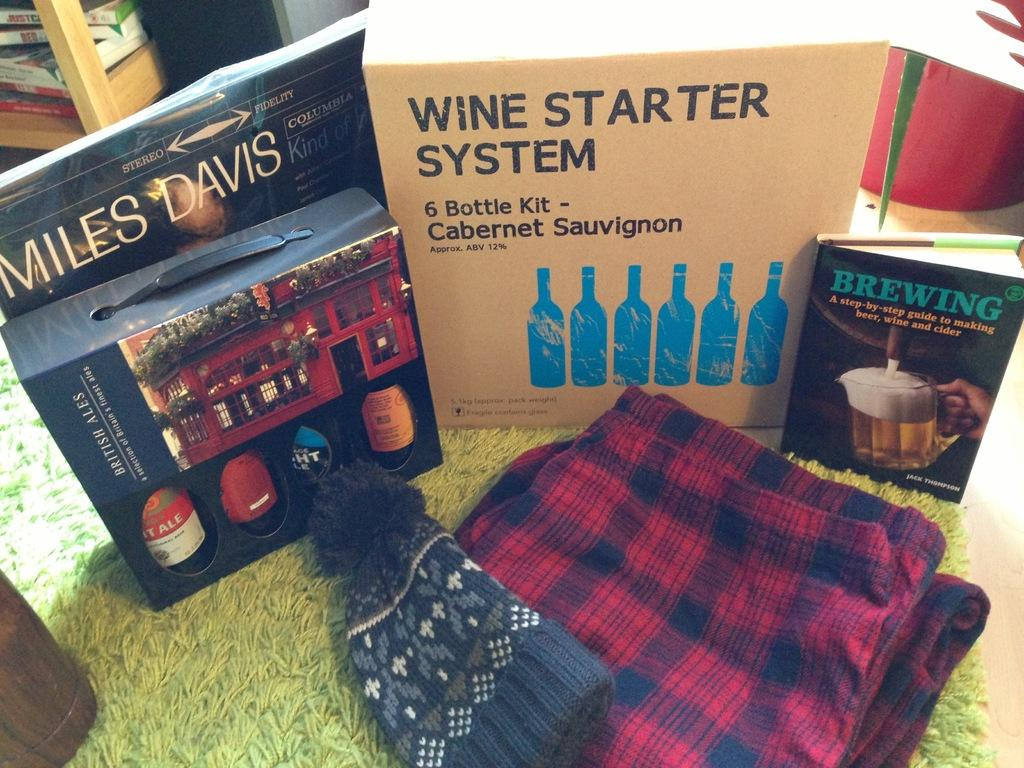<image>
Give a short and clear explanation of the subsequent image. A wine starter system 6 bottle kit of Cabernet Sauvignon sitting between two books. 